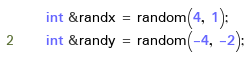<code> <loc_0><loc_0><loc_500><loc_500><_C_>	int &randx = random(4, 1);
	int &randy = random(-4, -2);
	</code> 